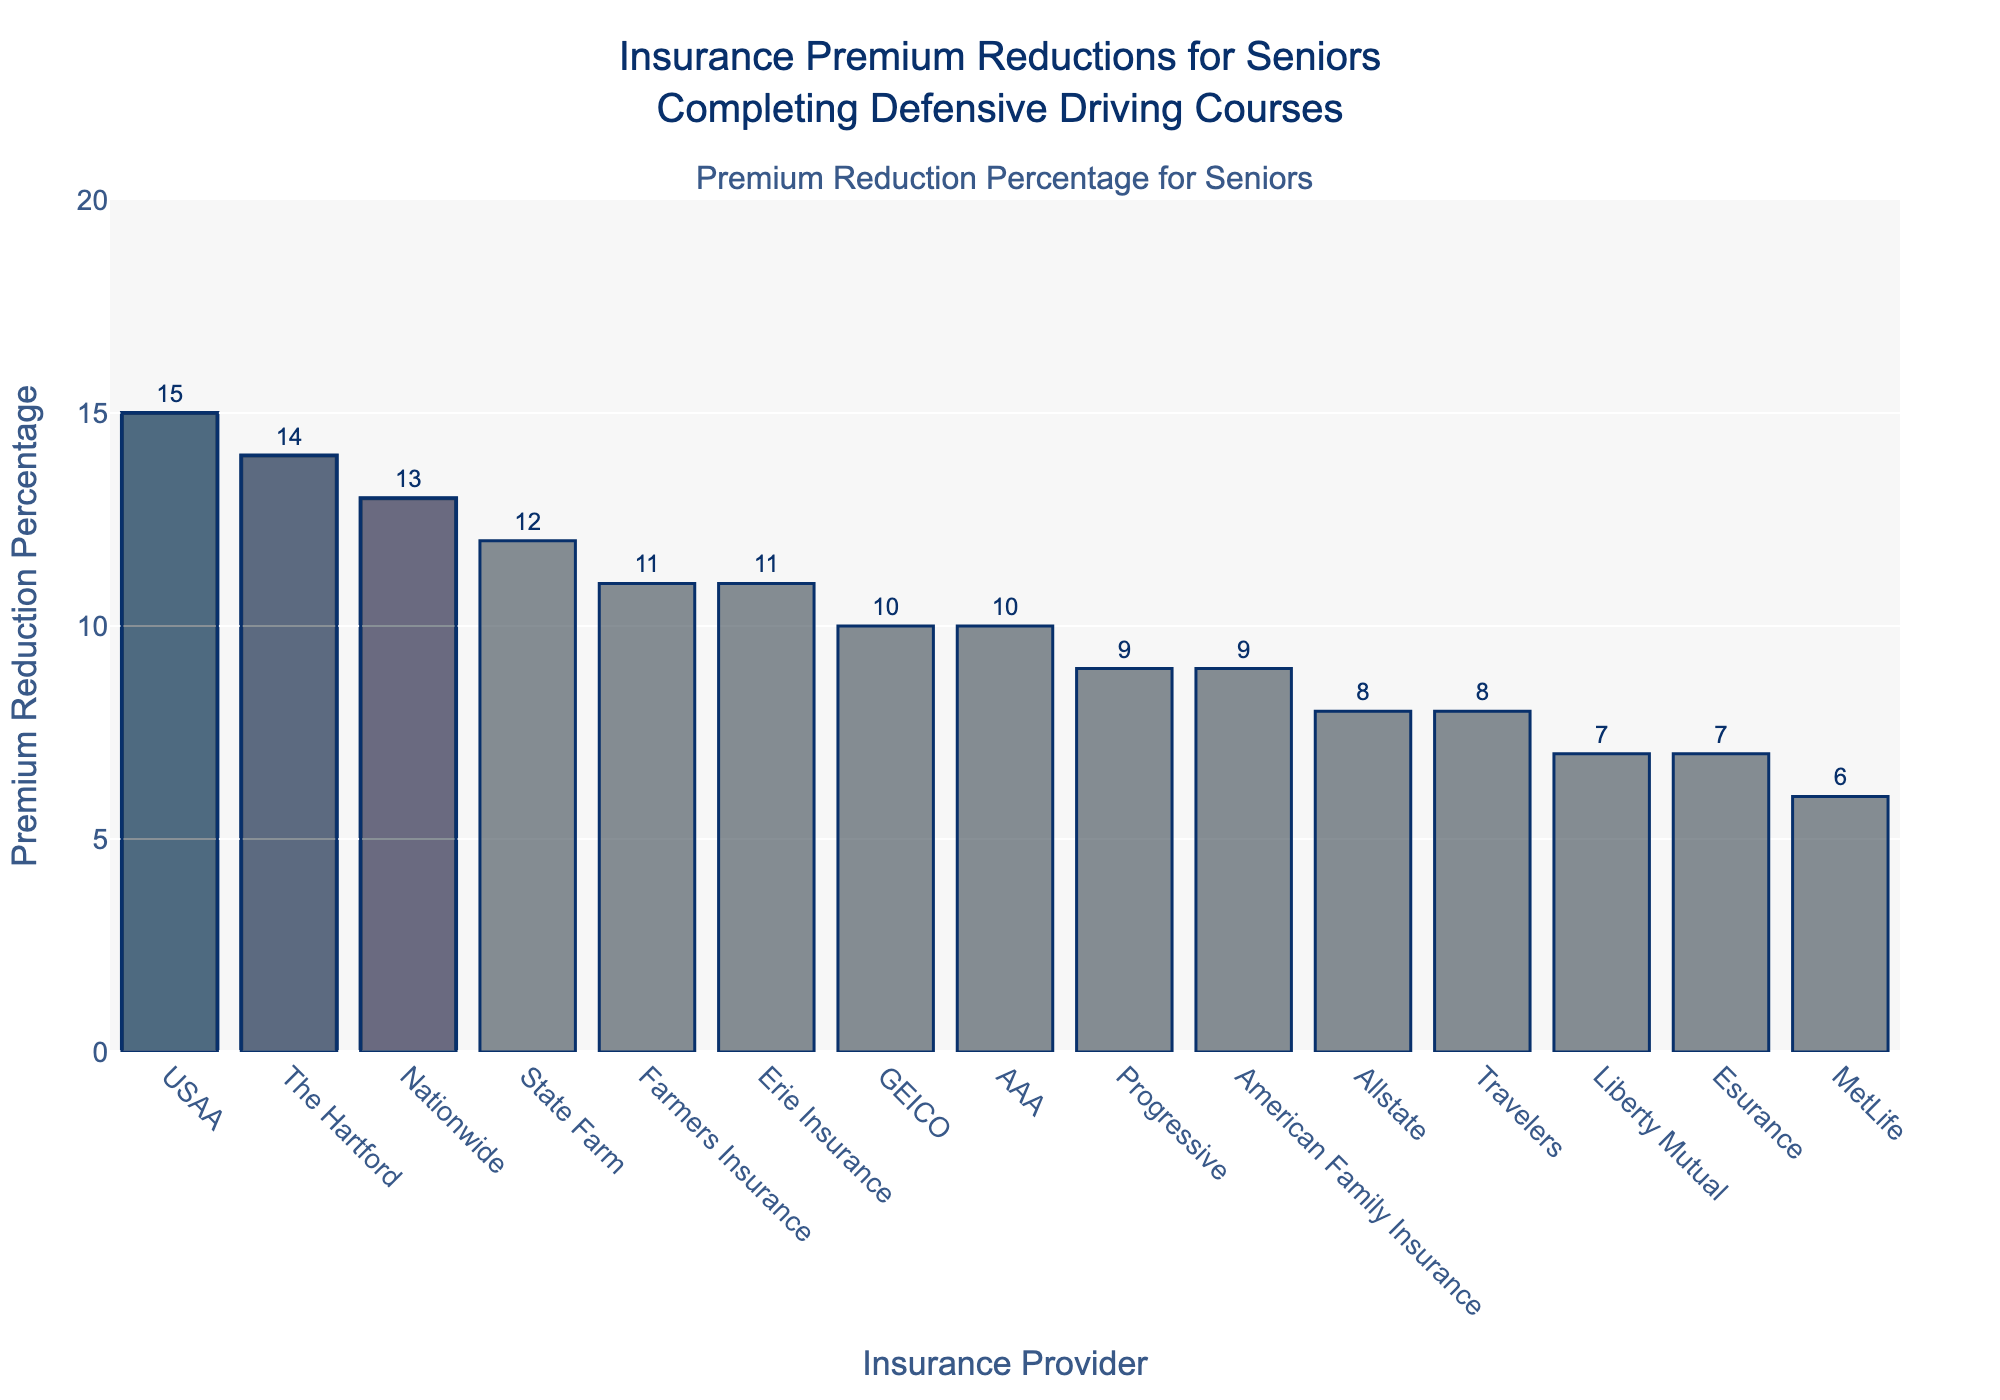Which insurance provider offers the highest premium reduction for seniors completing defensive driving courses? By looking at the top of the bar chart, we can see which insurance provider has the highest bar. This provider offers the highest premium reduction.
Answer: USAA Which insurance provider has the lowest premium reduction percentage? The provider with the shortest bar at the bottom of the chart represents the lowest premium reduction.
Answer: MetLife Among the top three insurance providers offering the highest premium reductions, which ranks second? We need to look at the second tallest bar in the chart, among the highlighted top three. This indicates the insurance provider that ranks second in premium reductions.
Answer: The Hartford What is the difference in premium reduction percentages between GEICO and Allstate? By examining the bars for GEICO and Allstate, find the difference in their heights, which reflect their premium reduction percentages. GEICO offers a 10% reduction, and Allstate offers 8%, so the difference is 10% - 8%.
Answer: 2% Which insurance providers offer exactly a 10% reduction in premiums? Identify the bars with a label of 10% on the chart and list the corresponding insurance providers.
Answer: GEICO and AAA What is the combined premium reduction percentage of Farmers Insurance and Erie Insurance? Check the heights of the bars for Farmers Insurance (11%) and Erie Insurance (11%) and add them together: 11 + 11.
Answer: 22% Which insurance provider offers a premium reduction percentage equal to the average of Travelers and Esurance? First, calculate the average premium reduction for Travelers (8%) and Esurance (7%): (8 + 7) / 2 = 7.5%. Then find the provider with a reduction matching this average.
Answer: None How many insurance providers offer a premium reduction percentage greater than 10%? Count the bars that exceed the 10% mark on the chart.
Answer: Six What is the median premium reduction percentage among all the insurance providers? To find the median, list all the premium reductions in ascending order and find the middle value. The sorted values are 6, 7, 7, 8, 8, 9, 9, 10, 10, 11, 11, 12, 13, 14, 15. The median is the 8th value in the list.
Answer: 10% By how much does Nationwide’s premium reduction exceed that of Liberty Mutual? Identify the premium reduction percentages for Nationwide (13%) and Liberty Mutual (7%) and calculate the difference: 13% - 7%.
Answer: 6% 